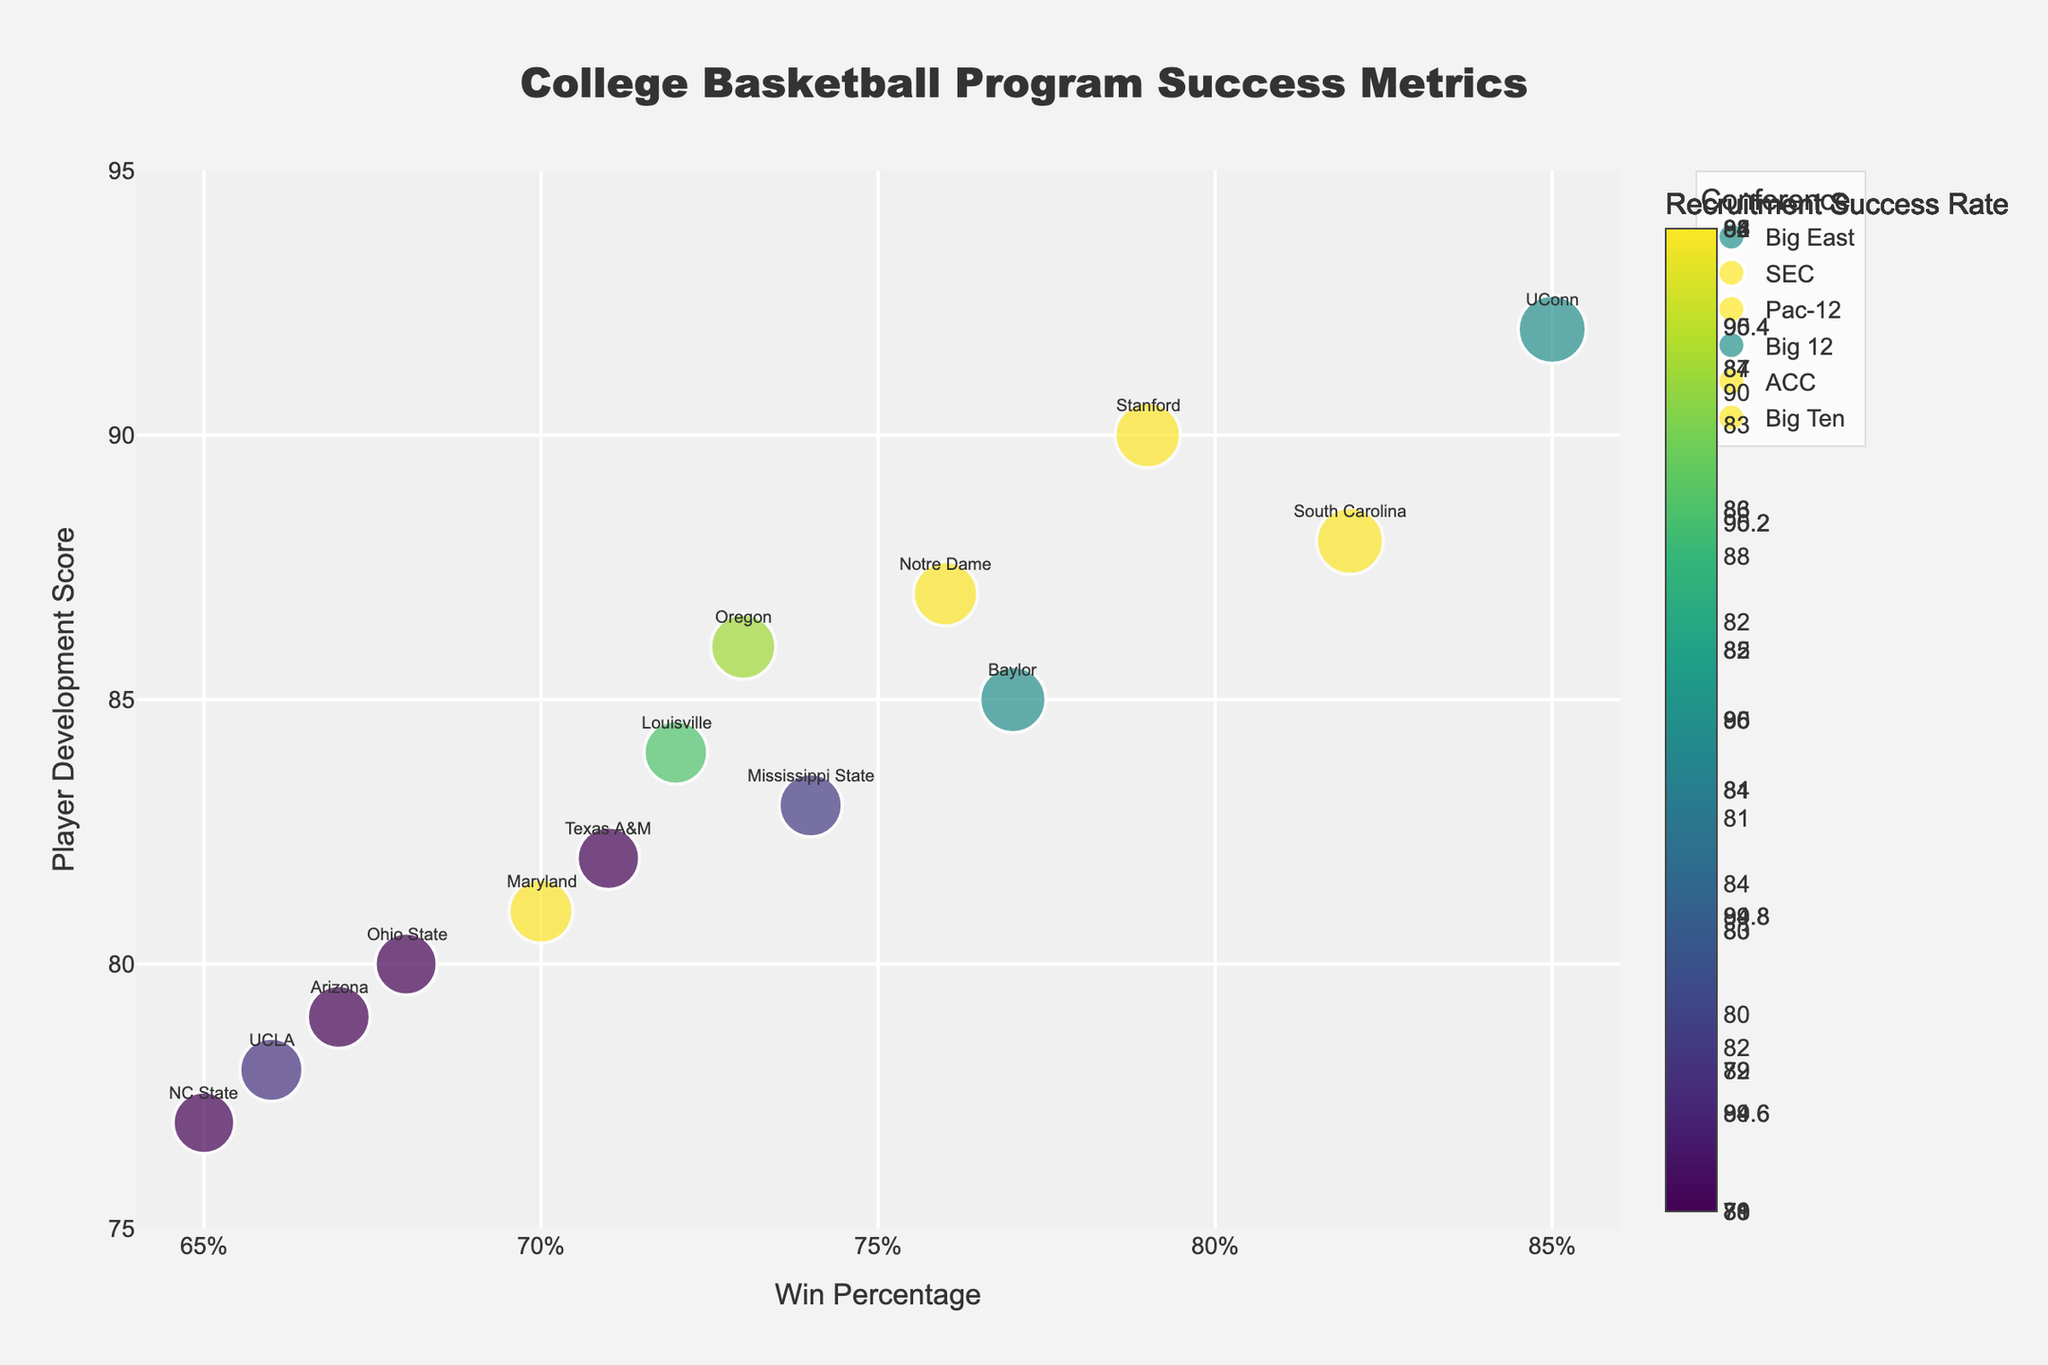What's the most popular color in the tech industry in 2023? To find the most popular color in the tech industry in 2023, look for the highest popularity value in the tech industry for that year. Locate the respective color associated with that value.
Answer: #1E90FF Which industry had the overall highest color popularity in 2023? Look at the highest popularity values in 2023 across all industries and identify which industry's plot has this value.
Answer: Tech (92) How does the popularity of the colors in the food & beverage industry trend from 2019 to 2023? Observe the points on the food & beverage subplot from 2019 to 2023 and note the direction of the popularity values. Count the changes and the direction (up or down) between years.
Answer: Up, then down, then up, then down Which color had the lowest popularity in the fashion industry in 2019? Look at the fashion industry's subplot for the popularity values in 2019 and identify the smallest value, then find the color associated with it.
Answer: #20B2AA How many industries had a color popularity above 85 in 2023? Check each subplot for the year 2023 and count how many industries had any color with a popularity value greater than 85.
Answer: Four (Fashion, Tech, Home Decor, Automotive) Which industry had the largest color popularity increase between 2020 and 2021? For each industry, calculate the difference in popularity values between 2020 and 2021, and determine which has the largest increase.
Answer: Tech (7 increase from 76 to 83) What was the trend in the popularity of the color #4682B4 in the Home Decor industry? Locate the points for the color #4682B4 in the home decor industry subplot and observe how its popularity changes over the years shown.
Answer: Stayed singular in 2022 In the automotive industry, which year and color had the second highest popularity? Look at the automotive subplot and identify the year and color with the second largest popularity value after the highest.
Answer: 2022, #FF0000 (86) 